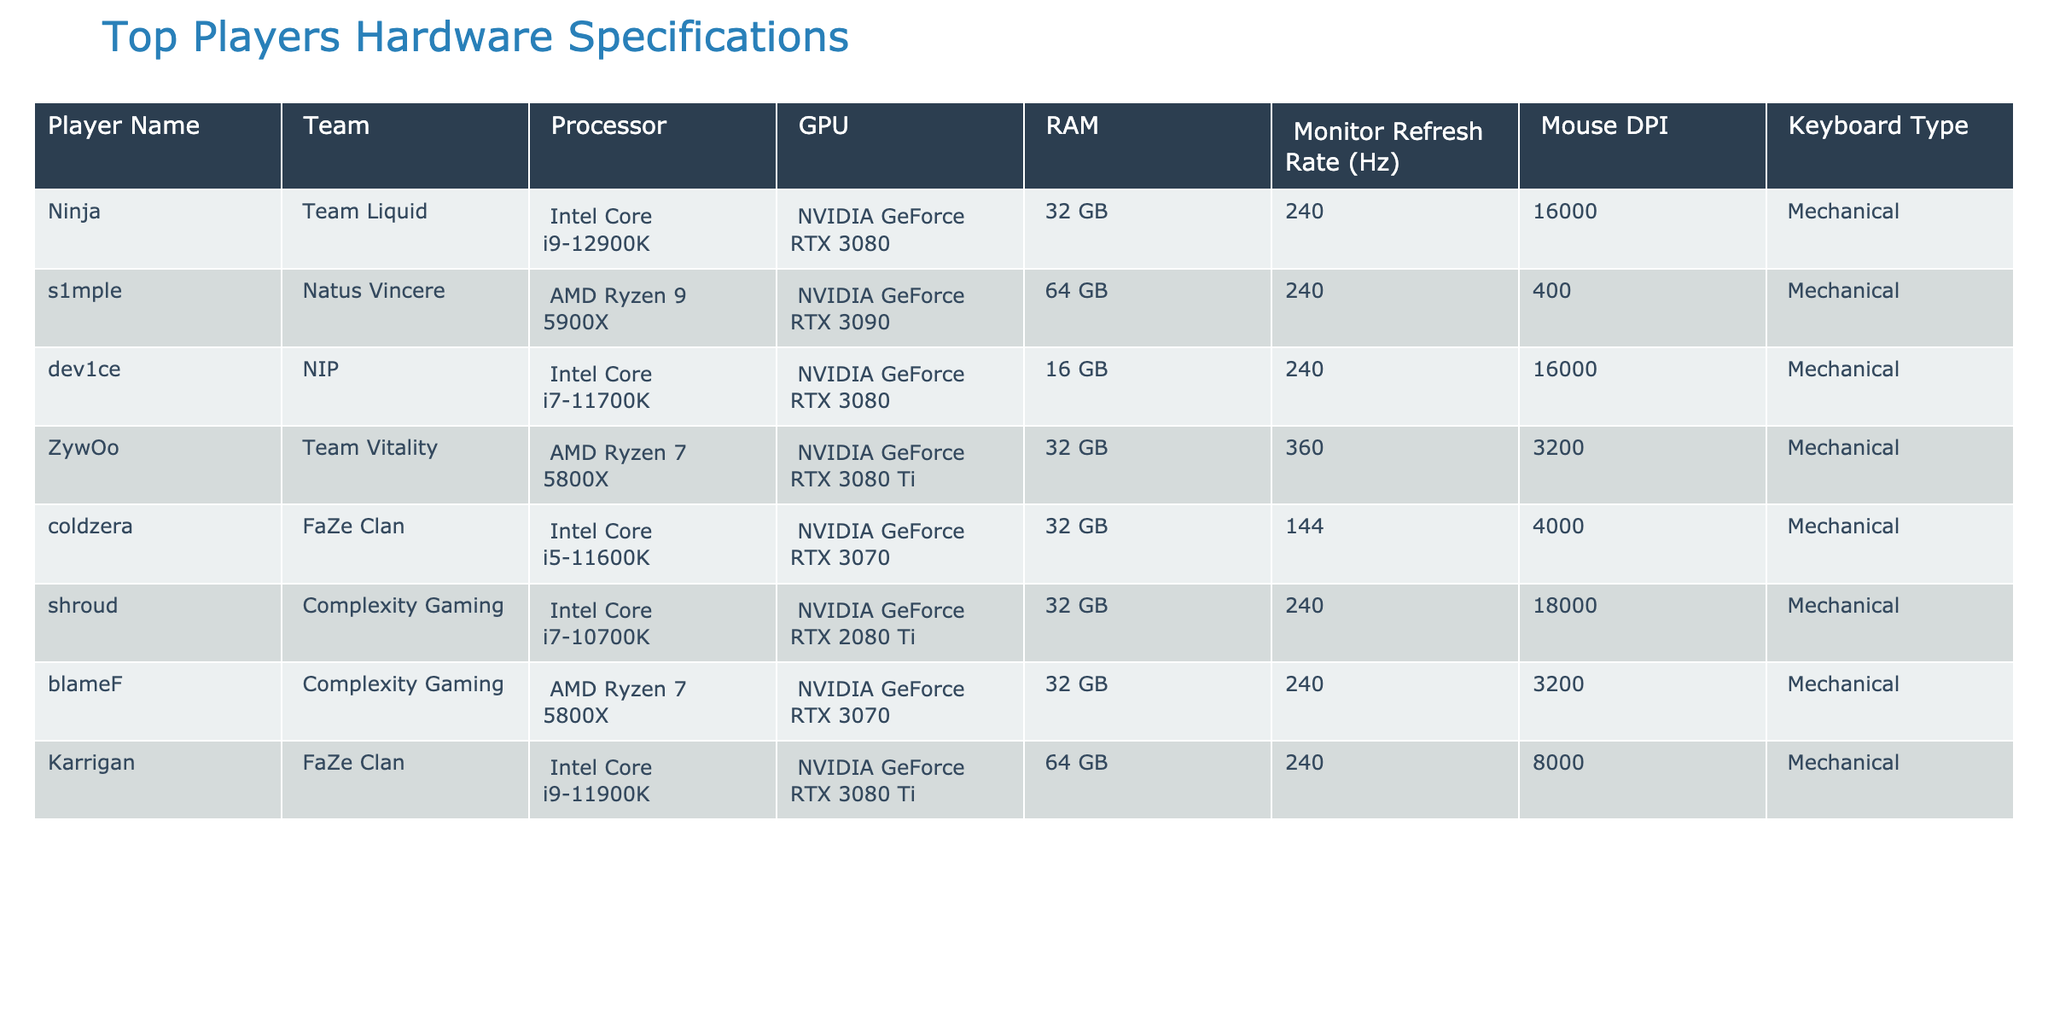What processor does s1mple use? Referring to the table, s1mple is listed under Natus Vincere, and the processor used by him is stated as AMD Ryzen 9 5900X.
Answer: AMD Ryzen 9 5900X Which player has the highest monitor refresh rate? Looking through the table, the player with the highest monitor refresh rate is ZywOo from Team Vitality at 360 Hz.
Answer: 360 Hz How many players use AMD processors? By counting the entries in the table, the players using AMD processors are s1mple, ZywOo, and blameF, totaling three players.
Answer: 3 players What is the average RAM used by these players? To find the average RAM, we sum the RAM values (32 + 64 + 16 + 32 + 32 + 32 + 64 = 272) and divide by the number of players (7). The average is 272 / 7 = approximately 38.86 GB.
Answer: Approximately 38.86 GB Does coldzera have a keyboard type that is mechanical? From the table entry for coldzera, it is shown that he uses a mechanical keyboard.
Answer: Yes Which player has the lowest DPI setting? By checking the mouse DPI column, coldzera has the lowest DPI setting listed as 400.
Answer: 400 Which player has the highest RAM and what is the value? In the table, both s1mple and Karrigan have the highest RAM of 64 GB. We identify both names with the specified value.
Answer: s1mple and Karrigan, 64 GB Is the GPU of dev1ce superior to that of shroud? Comparing the GPU from the table, dev1ce uses an NVIDIA GeForce RTX 3080, while shroud uses an NVIDIA GeForce RTX 2080 Ti, which is an older model, confirming that dev1ce has a superior GPU.
Answer: Yes What is the difference in DPI between the player with the highest DPI and the player with the lowest DPI? By examining the table, the highest DPI is from Ninja at 16000 and the lowest DPI is from coldzera at 400. The difference would be 16000 - 400 = 15600.
Answer: 15600 